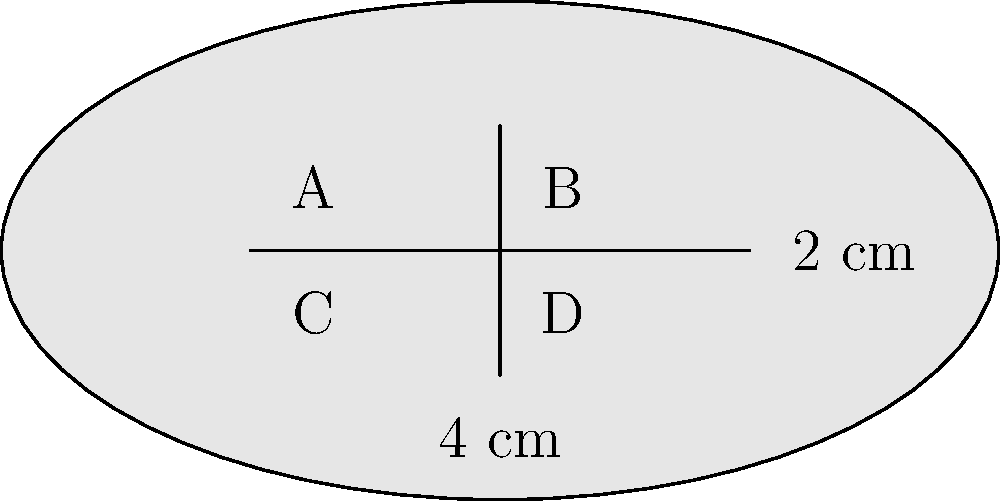A new drug solution is represented by the rectangle above, which is divided into four equal sections (A, B, C, and D). The rectangle has dimensions of 4 cm by 2 cm. If section A contains 20 mg of the active ingredient, and the concentration of the drug is uniform throughout the solution, calculate:

a) The total amount of the active ingredient in the entire solution.
b) The concentration of the active ingredient in mg/cm². Let's approach this step-by-step:

1) First, we need to calculate the area of the entire rectangle and each section:
   Total area = $4 \text{ cm} \times 2 \text{ cm} = 8 \text{ cm}^2$
   Area of each section = $8 \text{ cm}^2 \div 4 = 2 \text{ cm}^2$

2) We're told that section A contains 20 mg of the active ingredient. Since the concentration is uniform, each section contains the same amount.

3) To find the total amount of the active ingredient:
   Total amount = Amount in one section $\times$ Number of sections
   Total amount = $20 \text{ mg} \times 4 = 80 \text{ mg}$

4) To calculate the concentration, we use the formula:
   Concentration = $\frac{\text{Total amount of substance}}{\text{Total volume or area}}$

   Concentration = $\frac{80 \text{ mg}}{8 \text{ cm}^2} = 10 \text{ mg/cm}^2$

Therefore:
a) The total amount of the active ingredient is 80 mg.
b) The concentration of the active ingredient is 10 mg/cm².
Answer: a) 80 mg
b) 10 mg/cm² 